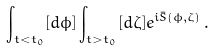<formula> <loc_0><loc_0><loc_500><loc_500>\int _ { t < t _ { 0 } } [ d \phi ] \int _ { t > t _ { 0 } } [ d \zeta ] e ^ { i \bar { S } ( \phi , \zeta ) } \, .</formula> 